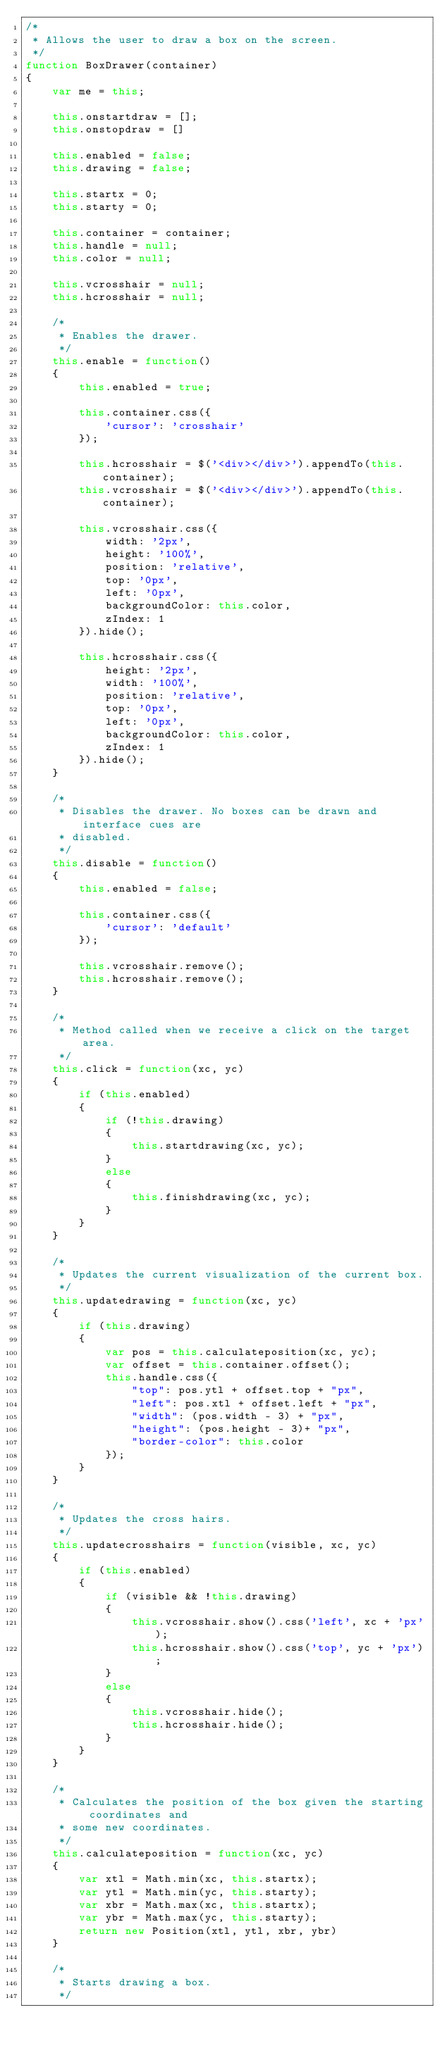<code> <loc_0><loc_0><loc_500><loc_500><_JavaScript_>/*
 * Allows the user to draw a box on the screen.
 */
function BoxDrawer(container)
{
    var me = this;

    this.onstartdraw = [];
    this.onstopdraw = []

    this.enabled = false;
    this.drawing = false;

    this.startx = 0;
    this.starty = 0;

    this.container = container;
    this.handle = null;
    this.color = null;

    this.vcrosshair = null;
    this.hcrosshair = null;

    /*
     * Enables the drawer.
     */
    this.enable = function()
    {
        this.enabled = true;

        this.container.css({
            'cursor': 'crosshair'
        });

        this.hcrosshair = $('<div></div>').appendTo(this.container);
        this.vcrosshair = $('<div></div>').appendTo(this.container);

        this.vcrosshair.css({
            width: '2px',
            height: '100%',
            position: 'relative',
            top: '0px',
            left: '0px',
            backgroundColor: this.color,
            zIndex: 1
        }).hide();

        this.hcrosshair.css({
            height: '2px',
            width: '100%',
            position: 'relative',
            top: '0px',
            left: '0px',
            backgroundColor: this.color,
            zIndex: 1
        }).hide();
    }

    /*
     * Disables the drawer. No boxes can be drawn and interface cues are
     * disabled.
     */
    this.disable = function()
    {
        this.enabled = false;

        this.container.css({
            'cursor': 'default'
        });

        this.vcrosshair.remove();
        this.hcrosshair.remove();
    }

    /*
     * Method called when we receive a click on the target area.
     */
    this.click = function(xc, yc)
    {
        if (this.enabled)
        {
            if (!this.drawing)
            {
                this.startdrawing(xc, yc);
            }
            else
            {
                this.finishdrawing(xc, yc);
            }
        }
    }

    /*
     * Updates the current visualization of the current box.
     */
    this.updatedrawing = function(xc, yc)
    {
        if (this.drawing)
        {
            var pos = this.calculateposition(xc, yc);
            var offset = this.container.offset();
            this.handle.css({
                "top": pos.ytl + offset.top + "px",
                "left": pos.xtl + offset.left + "px",
                "width": (pos.width - 3) + "px",
                "height": (pos.height - 3)+ "px",
                "border-color": this.color
            });
        }
    }

    /*
     * Updates the cross hairs.
     */
    this.updatecrosshairs = function(visible, xc, yc)
    {
        if (this.enabled)
        {
            if (visible && !this.drawing)
            {
                this.vcrosshair.show().css('left', xc + 'px');
                this.hcrosshair.show().css('top', yc + 'px');
            }
            else
            {
                this.vcrosshair.hide();
                this.hcrosshair.hide();
            }
        }
    }

    /*
     * Calculates the position of the box given the starting coordinates and
     * some new coordinates.
     */
    this.calculateposition = function(xc, yc)
    {
        var xtl = Math.min(xc, this.startx);
        var ytl = Math.min(yc, this.starty);
        var xbr = Math.max(xc, this.startx);
        var ybr = Math.max(yc, this.starty);
        return new Position(xtl, ytl, xbr, ybr)
    }

    /*
     * Starts drawing a box.
     */</code> 